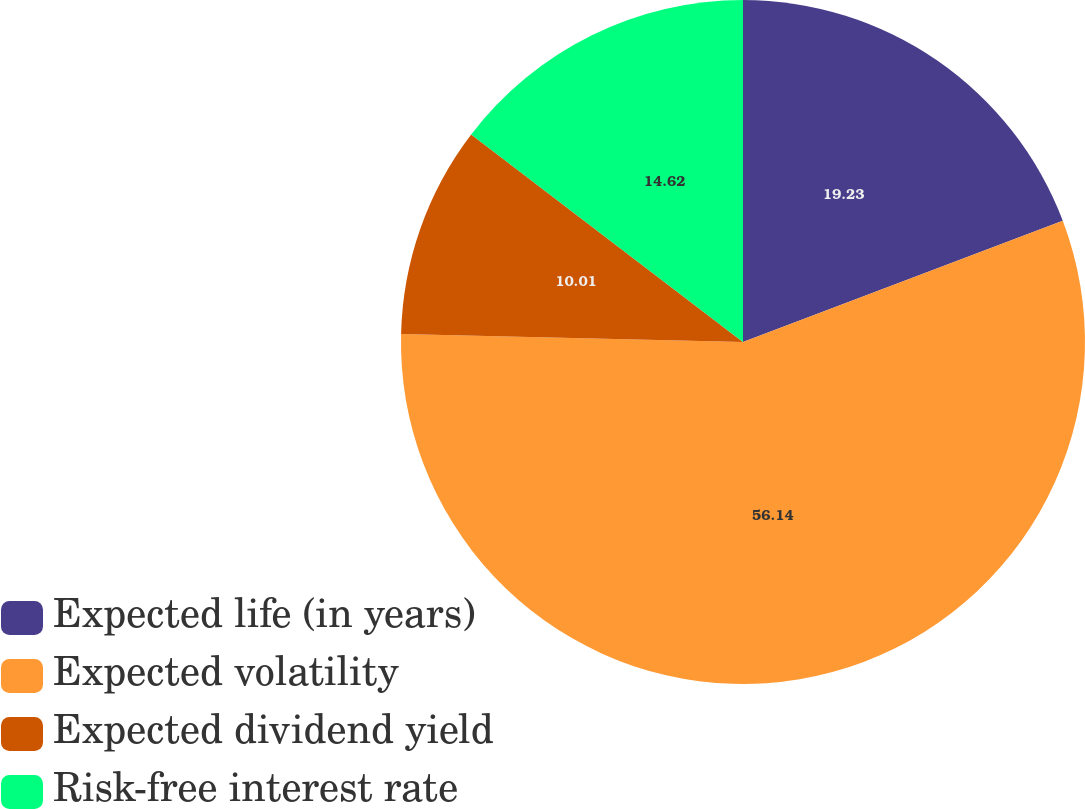<chart> <loc_0><loc_0><loc_500><loc_500><pie_chart><fcel>Expected life (in years)<fcel>Expected volatility<fcel>Expected dividend yield<fcel>Risk-free interest rate<nl><fcel>19.23%<fcel>56.14%<fcel>10.01%<fcel>14.62%<nl></chart> 